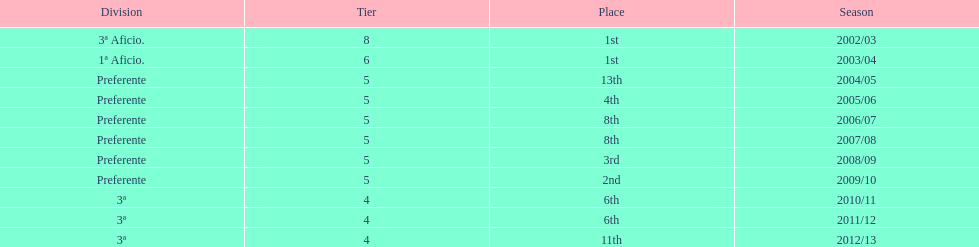Which division placed more than aficio 1a and 3a? Preferente. 